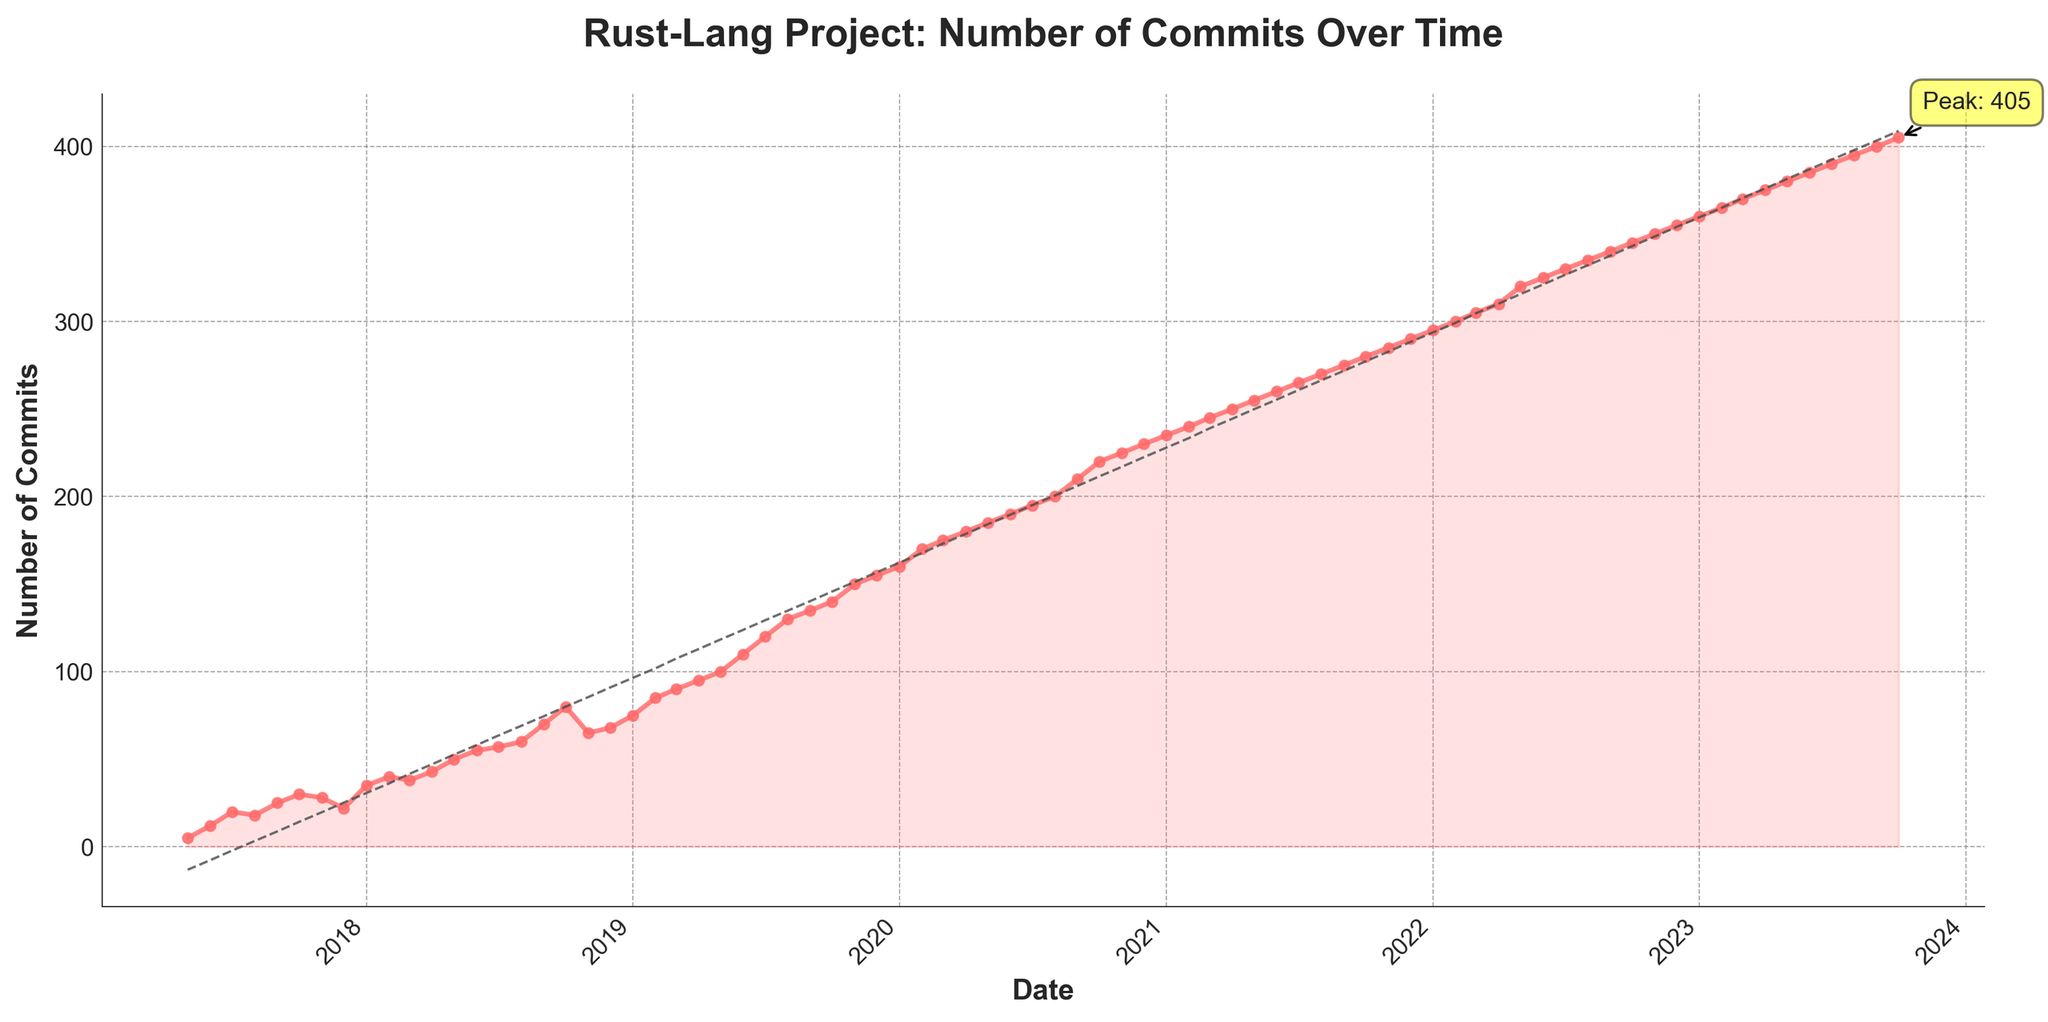What is the title of the plot? The title is displayed at the top center of the plot in bold text. It reads, "Rust-Lang Project: Number of Commits Over Time".
Answer: Rust-Lang Project: Number of Commits Over Time What is the highest number of commits recorded? The highest number of commits is noted by the annotation box labeled "Peak: 405" near the top right part of the plot.
Answer: 405 Over which period did the project see the most rapid increase in commits? By observing the steepest slope on the plot, it's evident that between June 2019 and November 2019, the number of commits increased significantly, marking the most rapid rise.
Answer: June 2019 - November 2019 How many commits were there in January 2018? Look at the data point corresponding to January 2018 on the x-axis and read the associated y-value, which shows the number of commits. The label at January 2018 indicates 35 commits.
Answer: 35 How does the number of commits in December 2020 compare to that in January 2021? Compare the data points for December 2020 and January 2021 on the plot. The number of commits in December 2020 is 230, and in January 2021, it is 235. January 2021 has 5 more commits than December 2020.
Answer: January 2021 has 5 more commits Which month had the second-highest increase in commits after the period with the most rapid increase identified earlier? After the rapid increase between June 2019 and November 2019, the next significant rise is observed between July 2018 and October 2018, from approximately 60 to 80 commits.
Answer: July 2018 - October 2018 What is the trend line shown on the plot, and what does it indicate about the project’s activity over time? The trend line is a dashed line that fits the overall data points on the plot. It indicates a positive trend, showing consistent growth in the number of commits over time.
Answer: Positive growth trend At which point does the plot show a slight decline in the number of commits, and why might this be significant? A slight decline is visible around November 2018, where commits drop from approximately 80 to 65. This could indicate a temporary slow down in development activity.
Answer: November 2018 What can be inferred about the project's growth from 2020 to 2021 based on the plot details? The plot shows a steady increase in the number of commits from 2020 to 2021, indicating consistent development and possibly a maturing phase of the project.
Answer: Steady increase and consistent development 